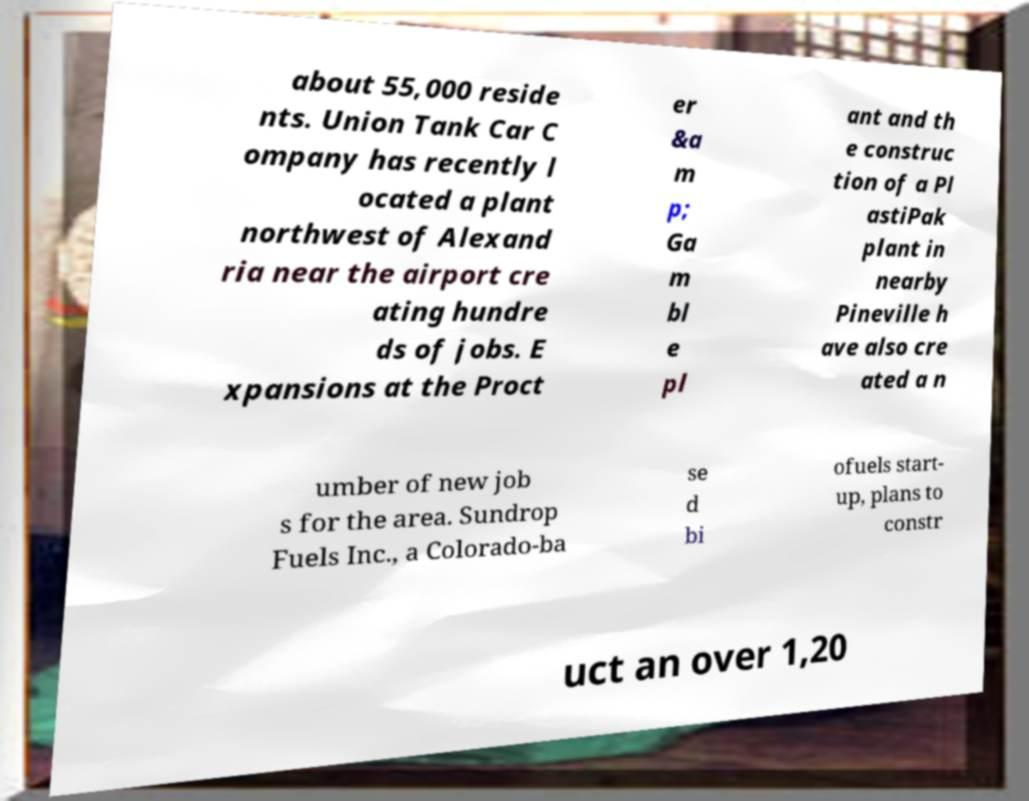Can you read and provide the text displayed in the image?This photo seems to have some interesting text. Can you extract and type it out for me? about 55,000 reside nts. Union Tank Car C ompany has recently l ocated a plant northwest of Alexand ria near the airport cre ating hundre ds of jobs. E xpansions at the Proct er &a m p; Ga m bl e pl ant and th e construc tion of a Pl astiPak plant in nearby Pineville h ave also cre ated a n umber of new job s for the area. Sundrop Fuels Inc., a Colorado-ba se d bi ofuels start- up, plans to constr uct an over 1,20 